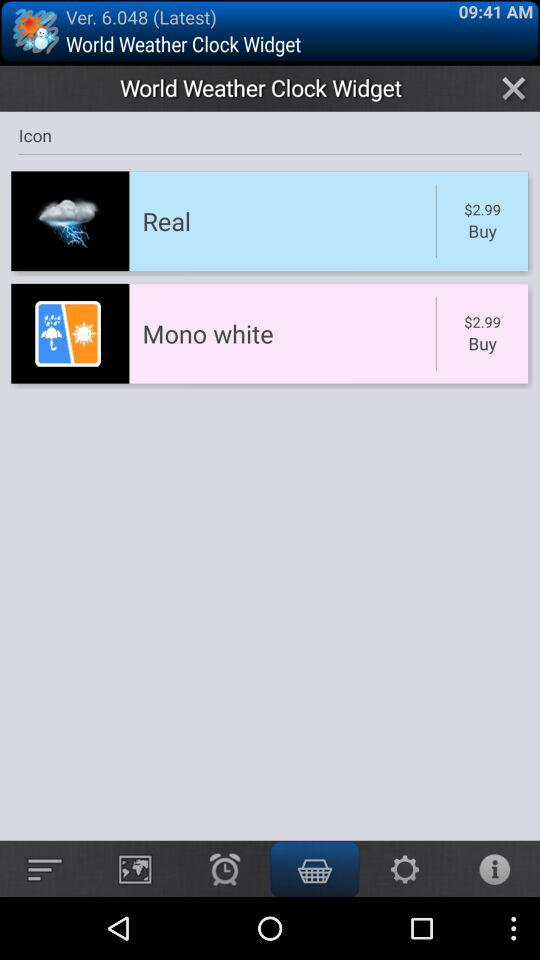Which days are selected for the alarm?
When the provided information is insufficient, respond with <no answer>. <no answer> 